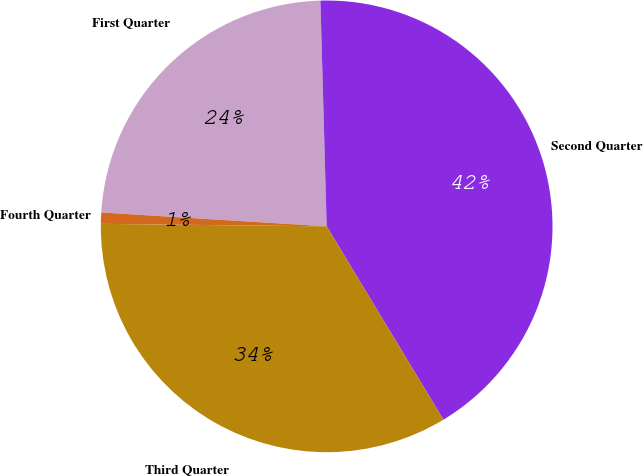<chart> <loc_0><loc_0><loc_500><loc_500><pie_chart><fcel>First Quarter<fcel>Second Quarter<fcel>Third Quarter<fcel>Fourth Quarter<nl><fcel>23.58%<fcel>41.79%<fcel>33.82%<fcel>0.8%<nl></chart> 